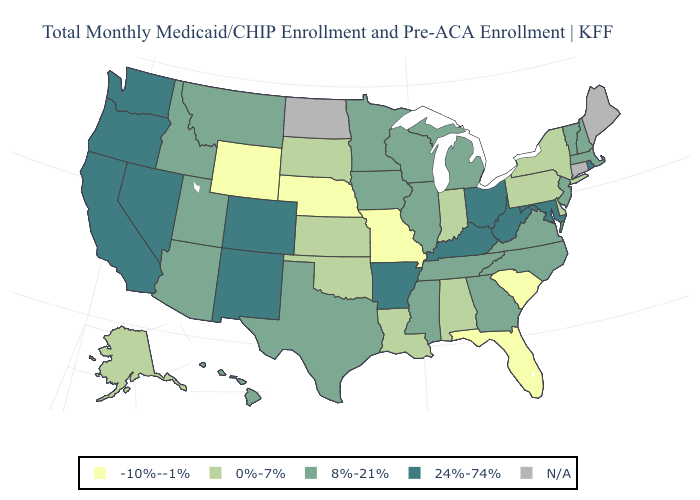What is the value of Ohio?
Write a very short answer. 24%-74%. Name the states that have a value in the range N/A?
Write a very short answer. Connecticut, Maine, North Dakota. Name the states that have a value in the range 8%-21%?
Short answer required. Arizona, Georgia, Hawaii, Idaho, Illinois, Iowa, Massachusetts, Michigan, Minnesota, Mississippi, Montana, New Hampshire, New Jersey, North Carolina, Tennessee, Texas, Utah, Vermont, Virginia, Wisconsin. What is the highest value in the MidWest ?
Short answer required. 24%-74%. Which states have the highest value in the USA?
Quick response, please. Arkansas, California, Colorado, Kentucky, Maryland, Nevada, New Mexico, Ohio, Oregon, Rhode Island, Washington, West Virginia. How many symbols are there in the legend?
Give a very brief answer. 5. What is the value of Massachusetts?
Short answer required. 8%-21%. Name the states that have a value in the range 8%-21%?
Concise answer only. Arizona, Georgia, Hawaii, Idaho, Illinois, Iowa, Massachusetts, Michigan, Minnesota, Mississippi, Montana, New Hampshire, New Jersey, North Carolina, Tennessee, Texas, Utah, Vermont, Virginia, Wisconsin. What is the value of Pennsylvania?
Keep it brief. 0%-7%. Name the states that have a value in the range -10%--1%?
Quick response, please. Florida, Missouri, Nebraska, South Carolina, Wyoming. Name the states that have a value in the range 8%-21%?
Be succinct. Arizona, Georgia, Hawaii, Idaho, Illinois, Iowa, Massachusetts, Michigan, Minnesota, Mississippi, Montana, New Hampshire, New Jersey, North Carolina, Tennessee, Texas, Utah, Vermont, Virginia, Wisconsin. 